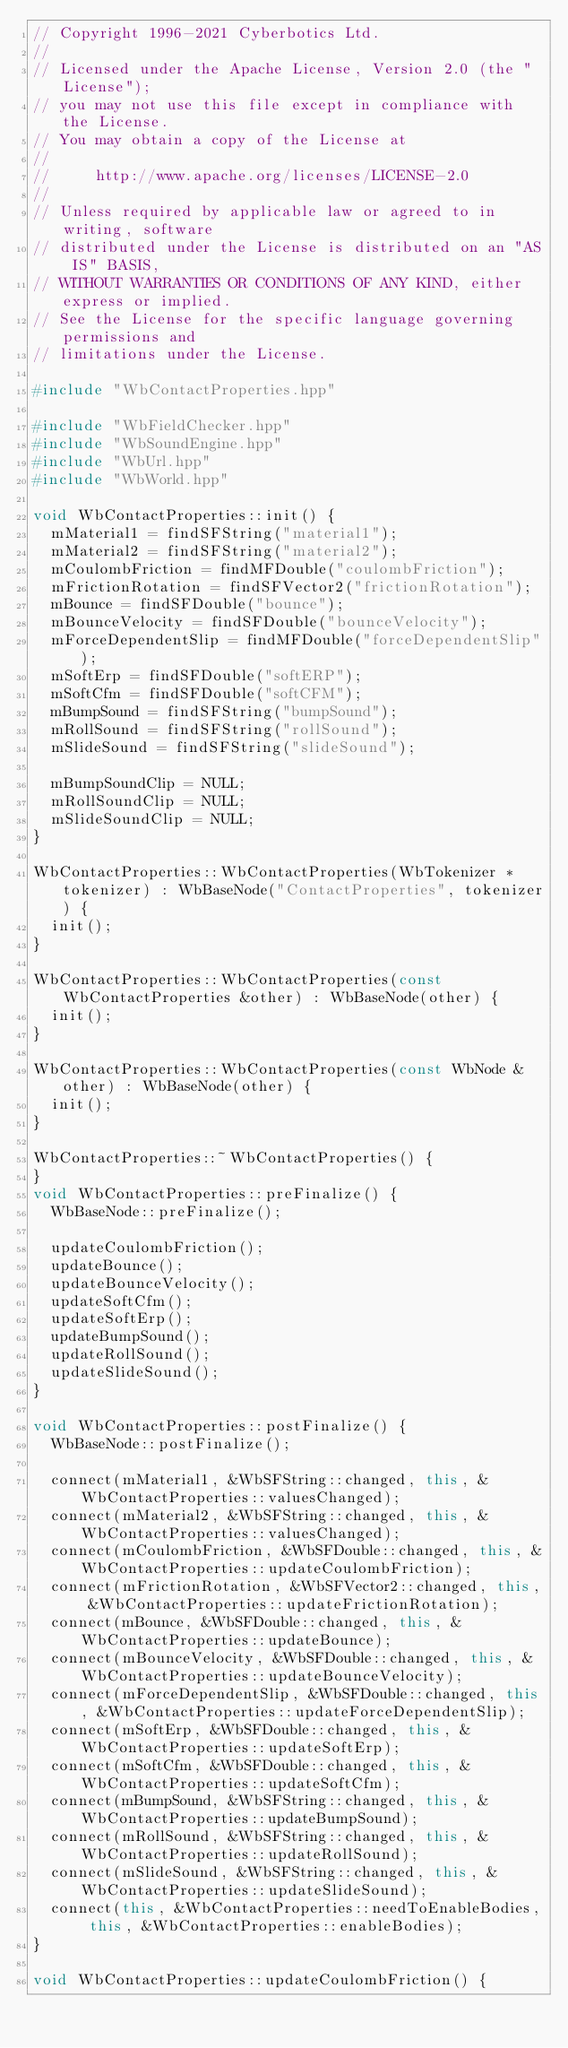Convert code to text. <code><loc_0><loc_0><loc_500><loc_500><_C++_>// Copyright 1996-2021 Cyberbotics Ltd.
//
// Licensed under the Apache License, Version 2.0 (the "License");
// you may not use this file except in compliance with the License.
// You may obtain a copy of the License at
//
//     http://www.apache.org/licenses/LICENSE-2.0
//
// Unless required by applicable law or agreed to in writing, software
// distributed under the License is distributed on an "AS IS" BASIS,
// WITHOUT WARRANTIES OR CONDITIONS OF ANY KIND, either express or implied.
// See the License for the specific language governing permissions and
// limitations under the License.

#include "WbContactProperties.hpp"

#include "WbFieldChecker.hpp"
#include "WbSoundEngine.hpp"
#include "WbUrl.hpp"
#include "WbWorld.hpp"

void WbContactProperties::init() {
  mMaterial1 = findSFString("material1");
  mMaterial2 = findSFString("material2");
  mCoulombFriction = findMFDouble("coulombFriction");
  mFrictionRotation = findSFVector2("frictionRotation");
  mBounce = findSFDouble("bounce");
  mBounceVelocity = findSFDouble("bounceVelocity");
  mForceDependentSlip = findMFDouble("forceDependentSlip");
  mSoftErp = findSFDouble("softERP");
  mSoftCfm = findSFDouble("softCFM");
  mBumpSound = findSFString("bumpSound");
  mRollSound = findSFString("rollSound");
  mSlideSound = findSFString("slideSound");

  mBumpSoundClip = NULL;
  mRollSoundClip = NULL;
  mSlideSoundClip = NULL;
}

WbContactProperties::WbContactProperties(WbTokenizer *tokenizer) : WbBaseNode("ContactProperties", tokenizer) {
  init();
}

WbContactProperties::WbContactProperties(const WbContactProperties &other) : WbBaseNode(other) {
  init();
}

WbContactProperties::WbContactProperties(const WbNode &other) : WbBaseNode(other) {
  init();
}

WbContactProperties::~WbContactProperties() {
}
void WbContactProperties::preFinalize() {
  WbBaseNode::preFinalize();

  updateCoulombFriction();
  updateBounce();
  updateBounceVelocity();
  updateSoftCfm();
  updateSoftErp();
  updateBumpSound();
  updateRollSound();
  updateSlideSound();
}

void WbContactProperties::postFinalize() {
  WbBaseNode::postFinalize();

  connect(mMaterial1, &WbSFString::changed, this, &WbContactProperties::valuesChanged);
  connect(mMaterial2, &WbSFString::changed, this, &WbContactProperties::valuesChanged);
  connect(mCoulombFriction, &WbSFDouble::changed, this, &WbContactProperties::updateCoulombFriction);
  connect(mFrictionRotation, &WbSFVector2::changed, this, &WbContactProperties::updateFrictionRotation);
  connect(mBounce, &WbSFDouble::changed, this, &WbContactProperties::updateBounce);
  connect(mBounceVelocity, &WbSFDouble::changed, this, &WbContactProperties::updateBounceVelocity);
  connect(mForceDependentSlip, &WbSFDouble::changed, this, &WbContactProperties::updateForceDependentSlip);
  connect(mSoftErp, &WbSFDouble::changed, this, &WbContactProperties::updateSoftErp);
  connect(mSoftCfm, &WbSFDouble::changed, this, &WbContactProperties::updateSoftCfm);
  connect(mBumpSound, &WbSFString::changed, this, &WbContactProperties::updateBumpSound);
  connect(mRollSound, &WbSFString::changed, this, &WbContactProperties::updateRollSound);
  connect(mSlideSound, &WbSFString::changed, this, &WbContactProperties::updateSlideSound);
  connect(this, &WbContactProperties::needToEnableBodies, this, &WbContactProperties::enableBodies);
}

void WbContactProperties::updateCoulombFriction() {</code> 